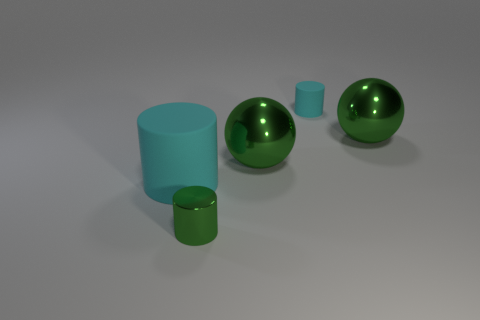There is a rubber cylinder to the left of the small rubber thing; is it the same color as the tiny rubber object?
Give a very brief answer. Yes. What number of objects are either small cylinders on the right side of the tiny green cylinder or cyan rubber cylinders?
Offer a terse response. 2. Is the number of green metal objects that are left of the tiny cyan object greater than the number of matte cylinders that are in front of the large cyan rubber thing?
Keep it short and to the point. Yes. Is the material of the tiny green cylinder the same as the big cyan object?
Offer a terse response. No. What is the shape of the large object that is made of the same material as the small cyan cylinder?
Your response must be concise. Cylinder. Are any big red objects visible?
Your answer should be very brief. No. There is a small green metallic cylinder in front of the large cyan rubber cylinder; are there any cyan cylinders right of it?
Your answer should be compact. Yes. What is the material of the green thing that is the same shape as the big cyan matte thing?
Your response must be concise. Metal. Is the number of metal spheres greater than the number of large yellow cylinders?
Provide a succinct answer. Yes. Do the metal cylinder and the large metallic sphere that is left of the small cyan matte thing have the same color?
Make the answer very short. Yes. 